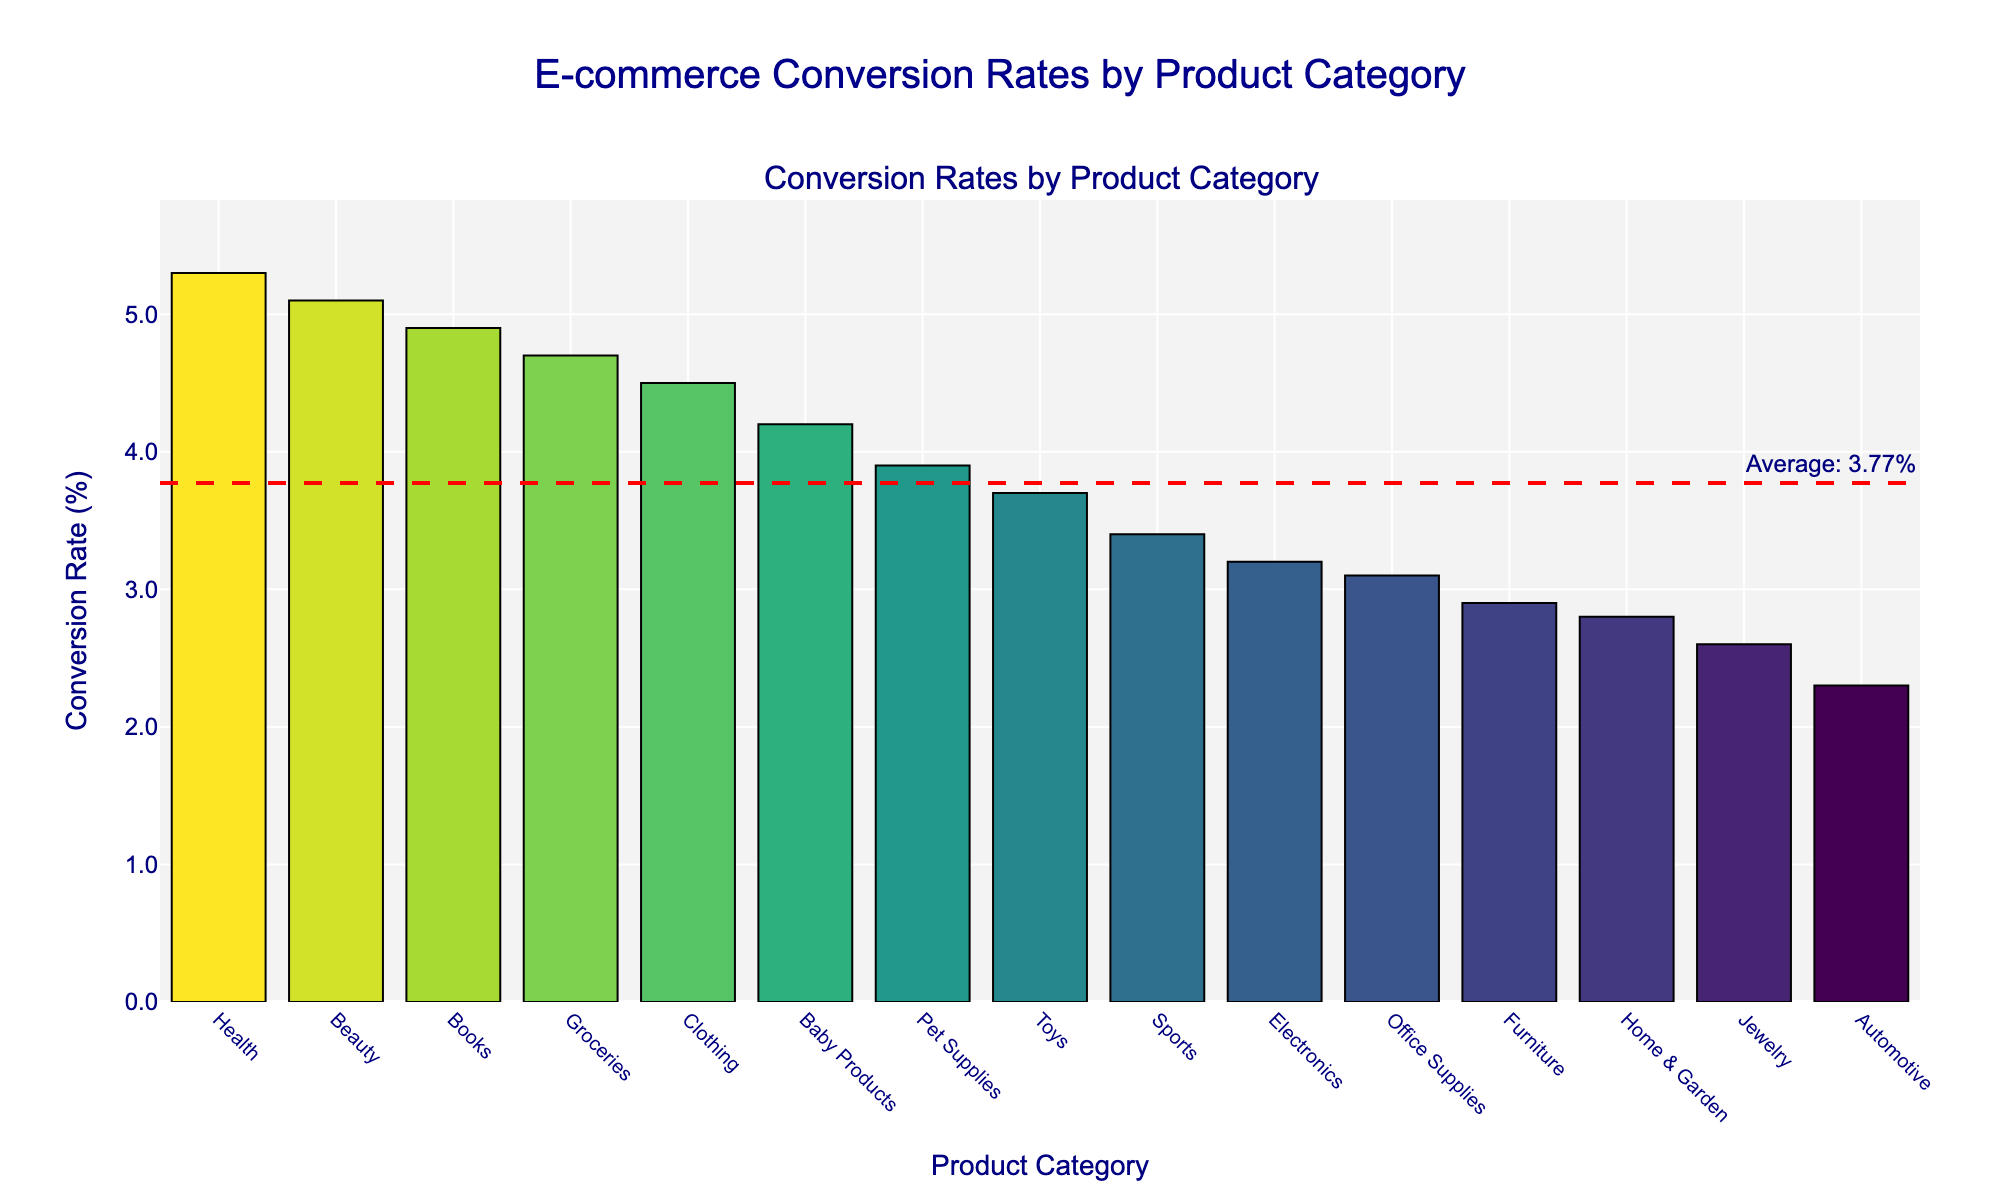What is the title of the plot? The title of the plot is displayed at the top center of the figure. To find the title, look above the bar graph where the text is larger and bold.
Answer: E-commerce Conversion Rates by Product Category How many product categories are shown in the plot? Count the bars in the bar graph. Each bar represents a product category.
Answer: 15 Which product category has the highest conversion rate? Identify the tallest bar in the plot since it represents the highest conversion rate. Hover over the bar to see the category name.
Answer: Health What is the conversion rate of the 'Electronics' category? Find the bar labeled 'Electronics' on the x-axis and read its height on the y-axis. Alternatively, hover over the bar to see the conversion rate.
Answer: 3.2% Which product category has the lowest conversion rate? Identify the shortest bar in the plot as it represents the lowest conversion rate. Hover over the bar to see the category name.
Answer: Automotive What is the average conversion rate across all product categories? Refer to the dashed red horizontal line representing the average conversion rate as labeled in the plot.
Answer: 3.9% What is the difference in conversion rate between the 'Beauty' and 'Office Supplies' categories? Find the conversion rates for both 'Beauty' and 'Office Supplies' by identifying their respective bars and noting their heights on the y-axis. Subtract the conversion rate of 'Office Supplies' from 'Beauty.'
Answer: 2.0% How many product categories have a conversion rate higher than the average? Identify bars that are taller than the red dashed average line. Count these bars.
Answer: 6 Are there more categories with conversion rates below or above the average? Count the number of bars taller than the red dashed average line for those above average and count the number of shorter bars for those below average. Compare the counts.
Answer: Below Which product category is closest to the average conversion rate? Locate the bar that intersects or is nearest to the red dashed average line within the plot. Hover over it to see the category name.
Answer: Pet Supplies 